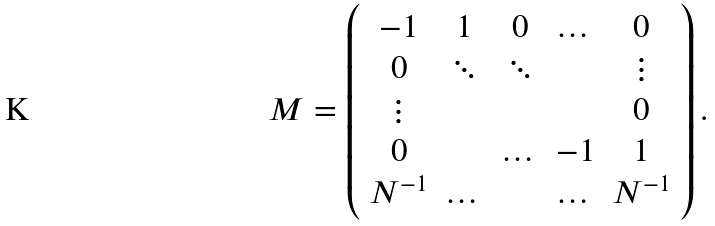<formula> <loc_0><loc_0><loc_500><loc_500>M = \left ( \begin{array} { c c c c c } - 1 & 1 & 0 & \dots & 0 \\ 0 & \ddots & \ddots & & \vdots \\ \vdots & & & & 0 \\ 0 & & \dots & - 1 & 1 \\ N ^ { - 1 } & \dots & & \dots & N ^ { - 1 } \\ \end{array} \right ) .</formula> 